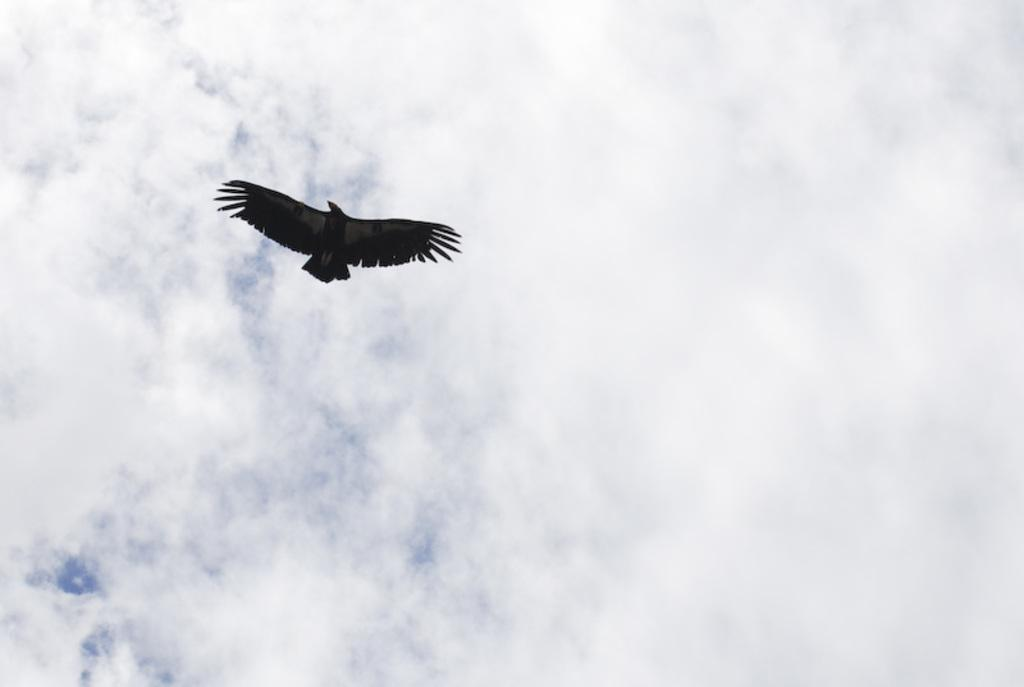What is the main subject of the image? There is a bird flying in the image. What is visible in the background of the image? There is a sky visible in the image. What can be observed in the sky? The sky contains clouds. What type of reaction does the mailbox have to the bird flying in the image? There is no mailbox present in the image, so it cannot have a reaction to the bird flying. 